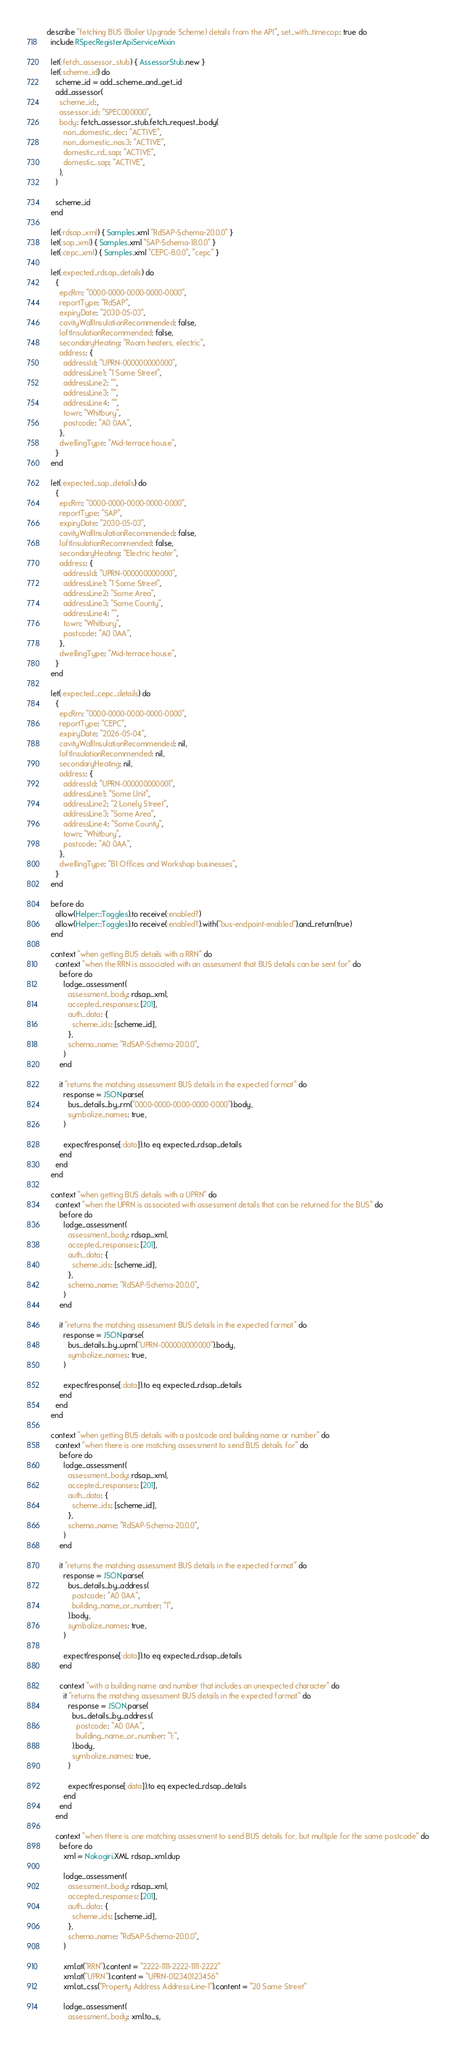<code> <loc_0><loc_0><loc_500><loc_500><_Ruby_>describe "fetching BUS (Boiler Upgrade Scheme) details from the API", set_with_timecop: true do
  include RSpecRegisterApiServiceMixin

  let(:fetch_assessor_stub) { AssessorStub.new }
  let(:scheme_id) do
    scheme_id = add_scheme_and_get_id
    add_assessor(
      scheme_id:,
      assessor_id: "SPEC000000",
      body: fetch_assessor_stub.fetch_request_body(
        non_domestic_dec: "ACTIVE",
        non_domestic_nos3: "ACTIVE",
        domestic_rd_sap: "ACTIVE",
        domestic_sap: "ACTIVE",
      ),
    )

    scheme_id
  end

  let(:rdsap_xml) { Samples.xml "RdSAP-Schema-20.0.0" }
  let(:sap_xml) { Samples.xml "SAP-Schema-18.0.0" }
  let(:cepc_xml) { Samples.xml "CEPC-8.0.0", "cepc" }

  let(:expected_rdsap_details) do
    {
      epcRrn: "0000-0000-0000-0000-0000",
      reportType: "RdSAP",
      expiryDate: "2030-05-03",
      cavityWallInsulationRecommended: false,
      loftInsulationRecommended: false,
      secondaryHeating: "Room heaters, electric",
      address: {
        addressId: "UPRN-000000000000",
        addressLine1: "1 Some Street",
        addressLine2: "",
        addressLine3: "",
        addressLine4: "",
        town: "Whitbury",
        postcode: "A0 0AA",
      },
      dwellingType: "Mid-terrace house",
    }
  end

  let(:expected_sap_details) do
    {
      epcRrn: "0000-0000-0000-0000-0000",
      reportType: "SAP",
      expiryDate: "2030-05-03",
      cavityWallInsulationRecommended: false,
      loftInsulationRecommended: false,
      secondaryHeating: "Electric heater",
      address: {
        addressId: "UPRN-000000000000",
        addressLine1: "1 Some Street",
        addressLine2: "Some Area",
        addressLine3: "Some County",
        addressLine4: "",
        town: "Whitbury",
        postcode: "A0 0AA",
      },
      dwellingType: "Mid-terrace house",
    }
  end

  let(:expected_cepc_details) do
    {
      epcRrn: "0000-0000-0000-0000-0000",
      reportType: "CEPC",
      expiryDate: "2026-05-04",
      cavityWallInsulationRecommended: nil,
      loftInsulationRecommended: nil,
      secondaryHeating: nil,
      address: {
        addressId: "UPRN-000000000001",
        addressLine1: "Some Unit",
        addressLine2: "2 Lonely Street",
        addressLine3: "Some Area",
        addressLine4: "Some County",
        town: "Whitbury",
        postcode: "A0 0AA",
      },
      dwellingType: "B1 Offices and Workshop businesses",
    }
  end

  before do
    allow(Helper::Toggles).to receive(:enabled?)
    allow(Helper::Toggles).to receive(:enabled?).with("bus-endpoint-enabled").and_return(true)
  end

  context "when getting BUS details with a RRN" do
    context "when the RRN is associated with an assessment that BUS details can be sent for" do
      before do
        lodge_assessment(
          assessment_body: rdsap_xml,
          accepted_responses: [201],
          auth_data: {
            scheme_ids: [scheme_id],
          },
          schema_name: "RdSAP-Schema-20.0.0",
        )
      end

      it "returns the matching assessment BUS details in the expected format" do
        response = JSON.parse(
          bus_details_by_rrn("0000-0000-0000-0000-0000").body,
          symbolize_names: true,
        )

        expect(response[:data]).to eq expected_rdsap_details
      end
    end
  end

  context "when getting BUS details with a UPRN" do
    context "when the UPRN is associated with assessment details that can be returned for the BUS" do
      before do
        lodge_assessment(
          assessment_body: rdsap_xml,
          accepted_responses: [201],
          auth_data: {
            scheme_ids: [scheme_id],
          },
          schema_name: "RdSAP-Schema-20.0.0",
        )
      end

      it "returns the matching assessment BUS details in the expected format" do
        response = JSON.parse(
          bus_details_by_uprn("UPRN-000000000000").body,
          symbolize_names: true,
        )

        expect(response[:data]).to eq expected_rdsap_details
      end
    end
  end

  context "when getting BUS details with a postcode and building name or number" do
    context "when there is one matching assessment to send BUS details for" do
      before do
        lodge_assessment(
          assessment_body: rdsap_xml,
          accepted_responses: [201],
          auth_data: {
            scheme_ids: [scheme_id],
          },
          schema_name: "RdSAP-Schema-20.0.0",
        )
      end

      it "returns the matching assessment BUS details in the expected format" do
        response = JSON.parse(
          bus_details_by_address(
            postcode: "A0 0AA",
            building_name_or_number: "1",
          ).body,
          symbolize_names: true,
        )

        expect(response[:data]).to eq expected_rdsap_details
      end

      context "with a building name and number that includes an unexpected character" do
        it "returns the matching assessment BUS details in the expected format" do
          response = JSON.parse(
            bus_details_by_address(
              postcode: "A0 0AA",
              building_name_or_number: "1:",
            ).body,
            symbolize_names: true,
          )

          expect(response[:data]).to eq expected_rdsap_details
        end
      end
    end

    context "when there is one matching assessment to send BUS details for, but multiple for the same postcode" do
      before do
        xml = Nokogiri.XML rdsap_xml.dup

        lodge_assessment(
          assessment_body: rdsap_xml,
          accepted_responses: [201],
          auth_data: {
            scheme_ids: [scheme_id],
          },
          schema_name: "RdSAP-Schema-20.0.0",
        )

        xml.at("RRN").content = "2222-1111-2222-1111-2222"
        xml.at("UPRN").content = "UPRN-012340123456"
        xml.at_css("Property Address Address-Line-1").content = "20 Some Street"

        lodge_assessment(
          assessment_body: xml.to_s,</code> 